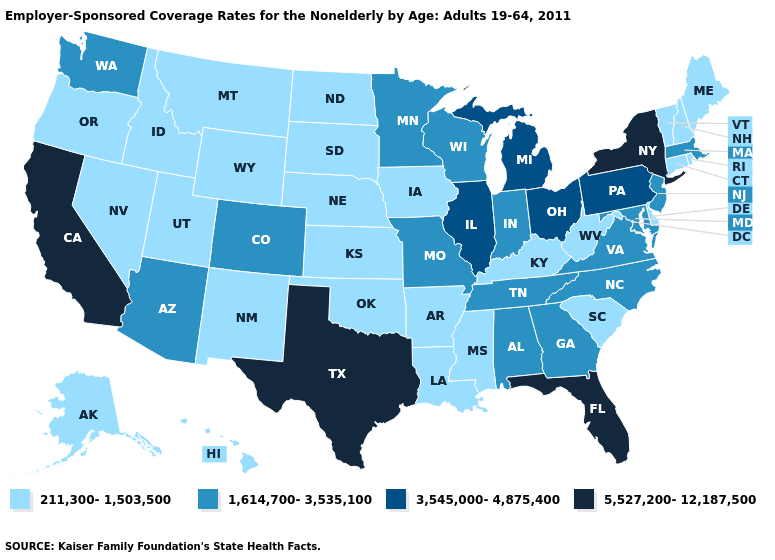Name the states that have a value in the range 211,300-1,503,500?
Quick response, please. Alaska, Arkansas, Connecticut, Delaware, Hawaii, Idaho, Iowa, Kansas, Kentucky, Louisiana, Maine, Mississippi, Montana, Nebraska, Nevada, New Hampshire, New Mexico, North Dakota, Oklahoma, Oregon, Rhode Island, South Carolina, South Dakota, Utah, Vermont, West Virginia, Wyoming. What is the highest value in the South ?
Be succinct. 5,527,200-12,187,500. Name the states that have a value in the range 5,527,200-12,187,500?
Short answer required. California, Florida, New York, Texas. Which states hav the highest value in the South?
Give a very brief answer. Florida, Texas. Does the map have missing data?
Give a very brief answer. No. Does Montana have a lower value than Mississippi?
Write a very short answer. No. Does North Carolina have the lowest value in the South?
Keep it brief. No. What is the value of Oklahoma?
Concise answer only. 211,300-1,503,500. Name the states that have a value in the range 5,527,200-12,187,500?
Give a very brief answer. California, Florida, New York, Texas. What is the value of West Virginia?
Quick response, please. 211,300-1,503,500. Does Illinois have a higher value than Texas?
Answer briefly. No. Name the states that have a value in the range 3,545,000-4,875,400?
Answer briefly. Illinois, Michigan, Ohio, Pennsylvania. Is the legend a continuous bar?
Give a very brief answer. No. Among the states that border Missouri , does Illinois have the lowest value?
Answer briefly. No. Name the states that have a value in the range 1,614,700-3,535,100?
Be succinct. Alabama, Arizona, Colorado, Georgia, Indiana, Maryland, Massachusetts, Minnesota, Missouri, New Jersey, North Carolina, Tennessee, Virginia, Washington, Wisconsin. 